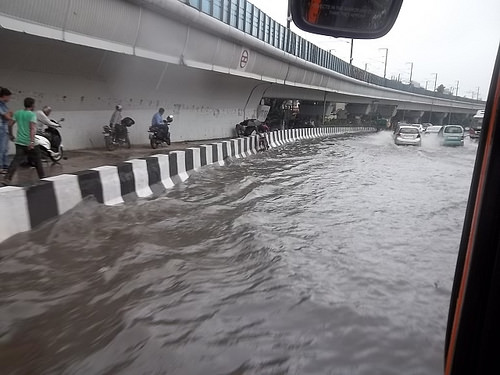<image>
Can you confirm if the car is on the water? Yes. Looking at the image, I can see the car is positioned on top of the water, with the water providing support. Is the car to the right of the wall? Yes. From this viewpoint, the car is positioned to the right side relative to the wall. 